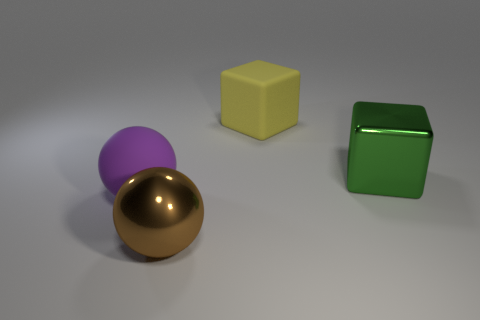Subtract 2 spheres. How many spheres are left? 0 Add 1 big cubes. How many objects exist? 5 Subtract all yellow cubes. Subtract all brown balls. How many cubes are left? 1 Subtract all purple cubes. How many brown spheres are left? 1 Subtract all small purple matte cubes. Subtract all large balls. How many objects are left? 2 Add 2 brown shiny objects. How many brown shiny objects are left? 3 Add 2 metallic objects. How many metallic objects exist? 4 Subtract 0 cyan cubes. How many objects are left? 4 